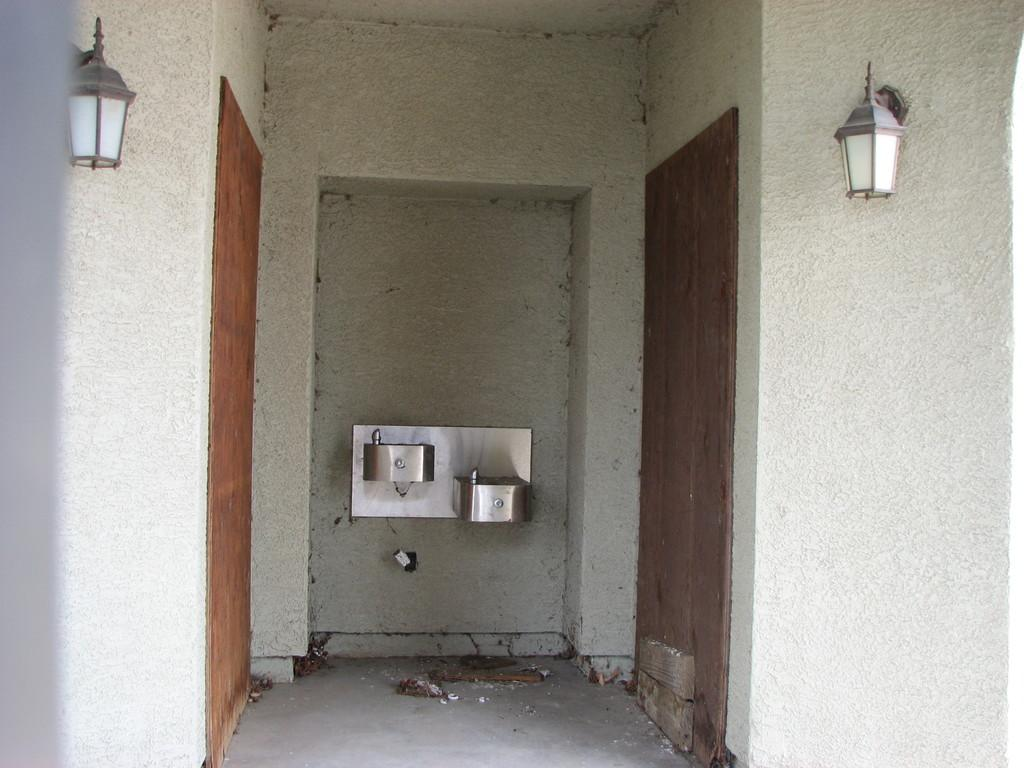What is attached to the wall in the image? There are lamps attached to the wall. What feature of the wall is mentioned in the facts? The wall has doors. Can you describe the object attached to the wall? Unfortunately, the facts do not provide enough information to describe the object attached to the wall. How does the flock of birds navigate the boat in the image? There is no boat or flock of birds present in the image. 